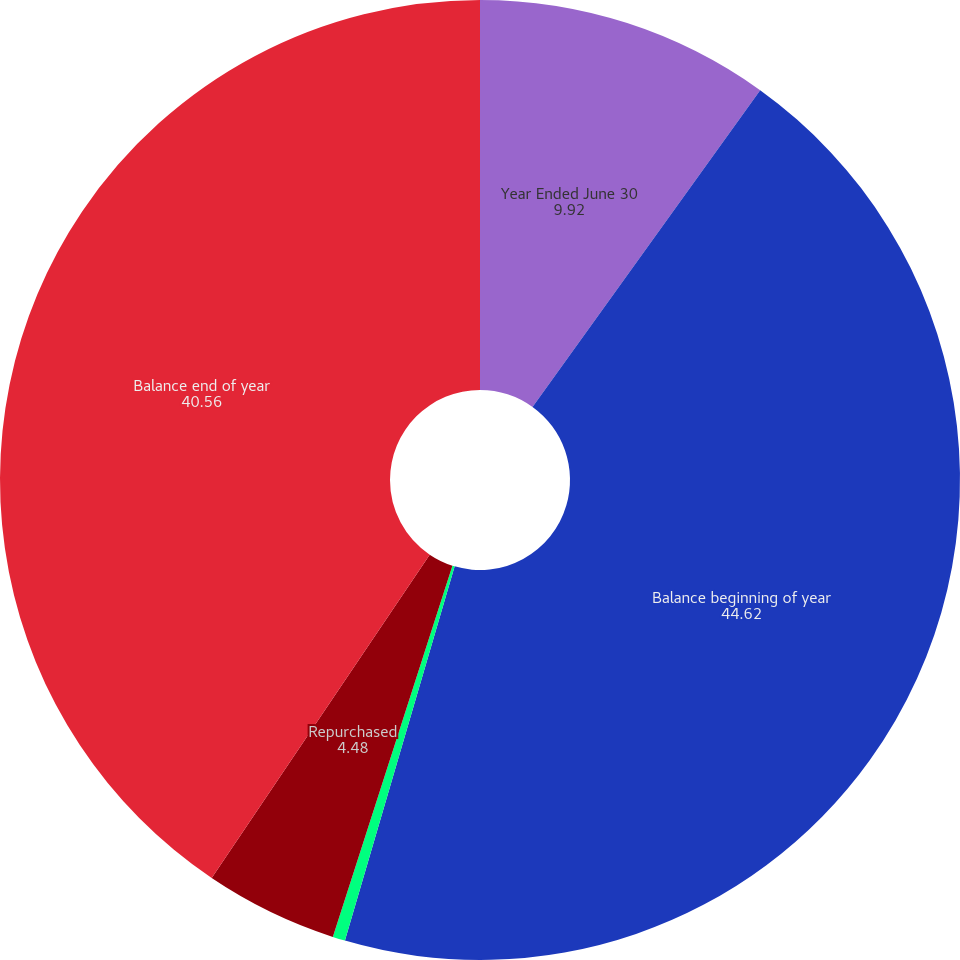<chart> <loc_0><loc_0><loc_500><loc_500><pie_chart><fcel>Year Ended June 30<fcel>Balance beginning of year<fcel>Issued<fcel>Repurchased<fcel>Balance end of year<nl><fcel>9.92%<fcel>44.62%<fcel>0.42%<fcel>4.48%<fcel>40.56%<nl></chart> 